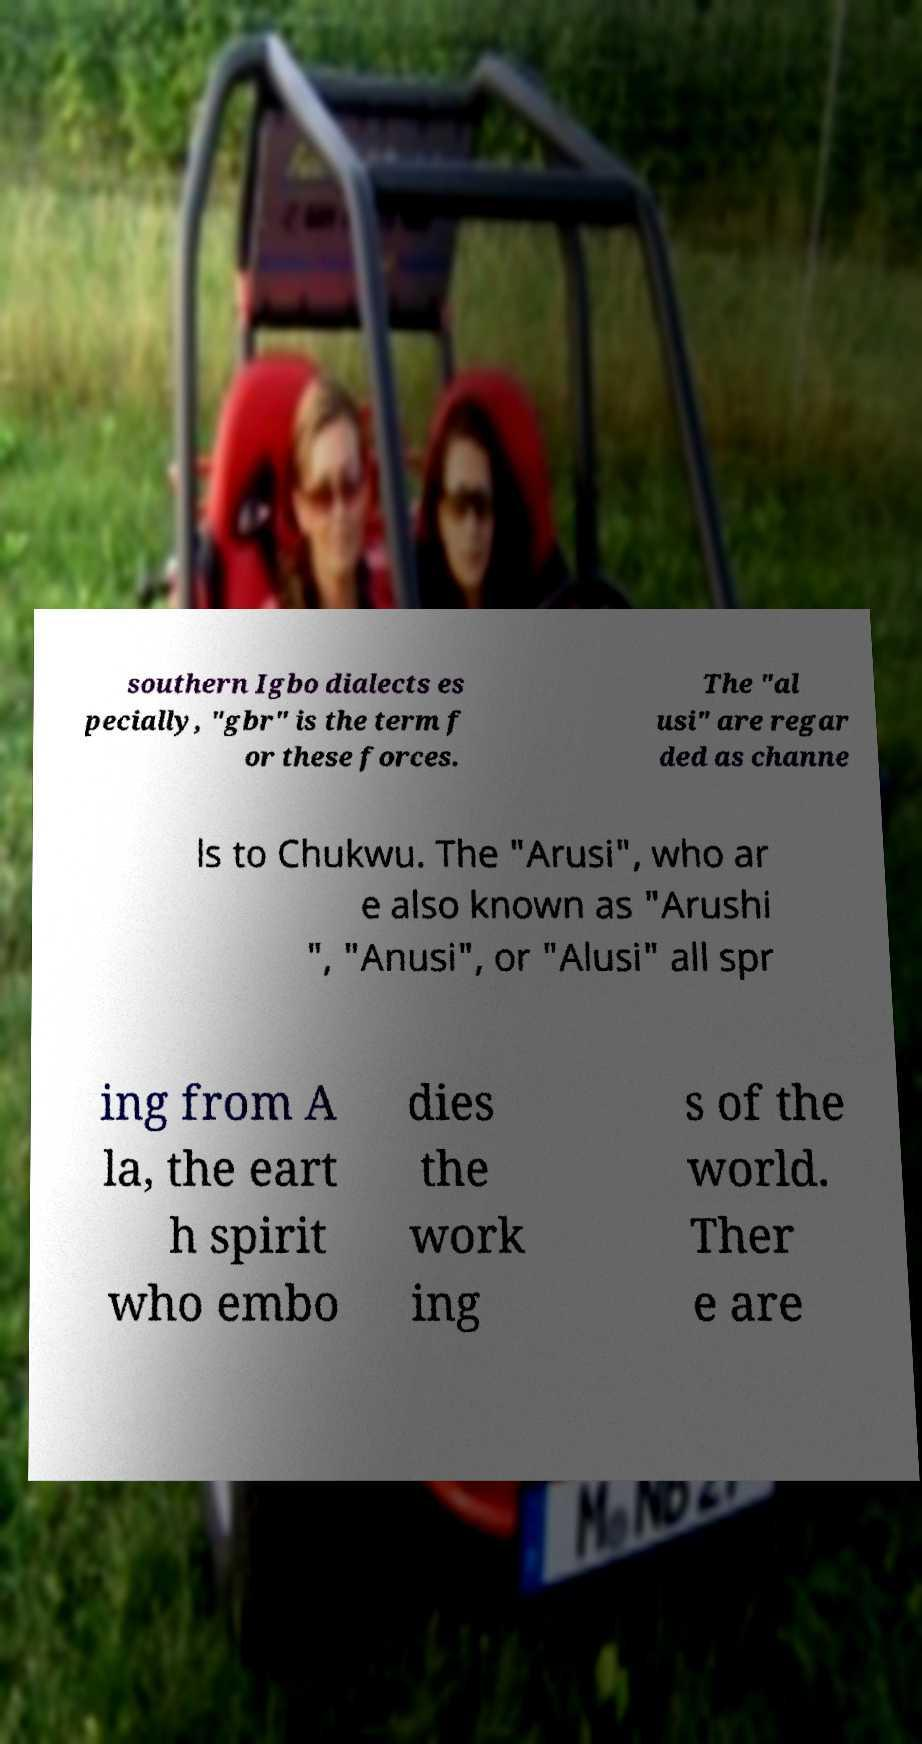Please read and relay the text visible in this image. What does it say? southern Igbo dialects es pecially, "gbr" is the term f or these forces. The "al usi" are regar ded as channe ls to Chukwu. The "Arusi", who ar e also known as "Arushi ", "Anusi", or "Alusi" all spr ing from A la, the eart h spirit who embo dies the work ing s of the world. Ther e are 